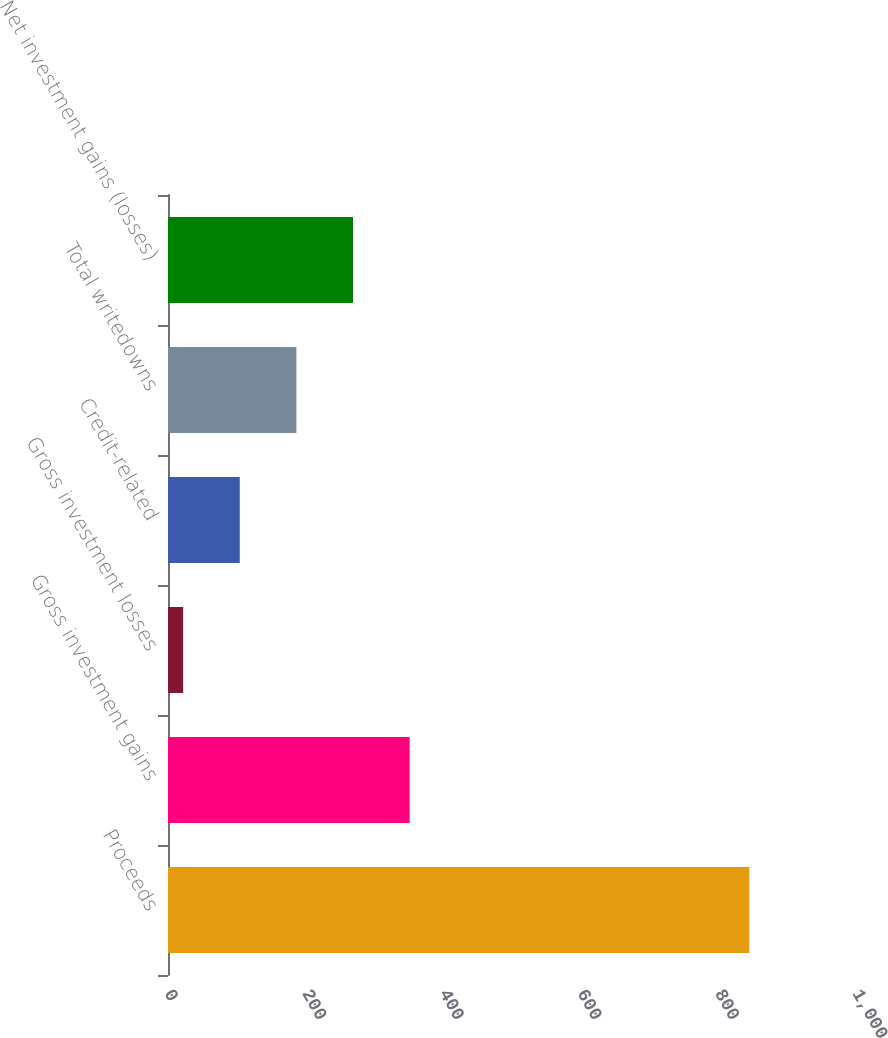Convert chart. <chart><loc_0><loc_0><loc_500><loc_500><bar_chart><fcel>Proceeds<fcel>Gross investment gains<fcel>Gross investment losses<fcel>Credit-related<fcel>Total writedowns<fcel>Net investment gains (losses)<nl><fcel>845<fcel>351.2<fcel>22<fcel>104.3<fcel>186.6<fcel>268.9<nl></chart> 